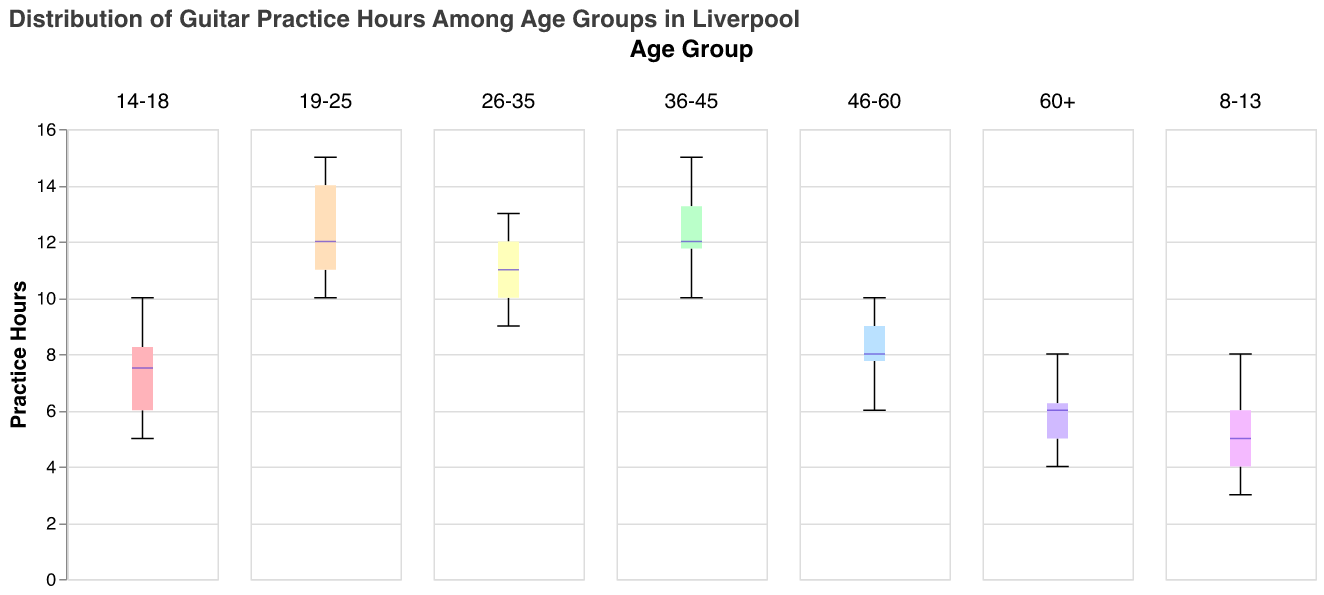What is the range of practice hours for the 19-25 age group? Look at the box plot for the 19-25 age group. Identify the minimum and maximum whiskers' values to determine the range.
Answer: 10-15 hours Which age group has the highest median practice hours? Observe the position of the median lines (colored differently) across all age groups. The highest median line indicates the highest median practice hours.
Answer: 19-25 What is the median practice hours for the 36-45 age group? Check the box plot for the 36-45 age group and identify the position of the median line.
Answer: 13 hours Which age group shows the most variation in practice hours? Look for the age group whose box plot has the longest interquartile range (the height of the box itself) and whiskers.
Answer: 8-13 In which age group do guitarists practice the least on average? Calculate the average practice hours for each age group by taking the sum of all practice hours and dividing by the number of data points in each age group. Observe which age group has the lowest average.
Answer: 60+ Are there any outliers in the 46-60 age group? Outliers in box plots are typically indicated by individual points that fall outside the whiskers. Check for any such points in the 46-60 age group.
Answer: No How does the interquartile range (IQR) of the 26-35 age group compare to the 8-13 age group? Compare the heights of the boxes (representing IQR) for the 26-35 and 8-13 age groups.
Answer: 26-35 IQR is smaller Which age group has the lowest minimum practice hours? Identify the position of the bottom whisker (minimum value) in each group and find the lowest one.
Answer: 8-13 